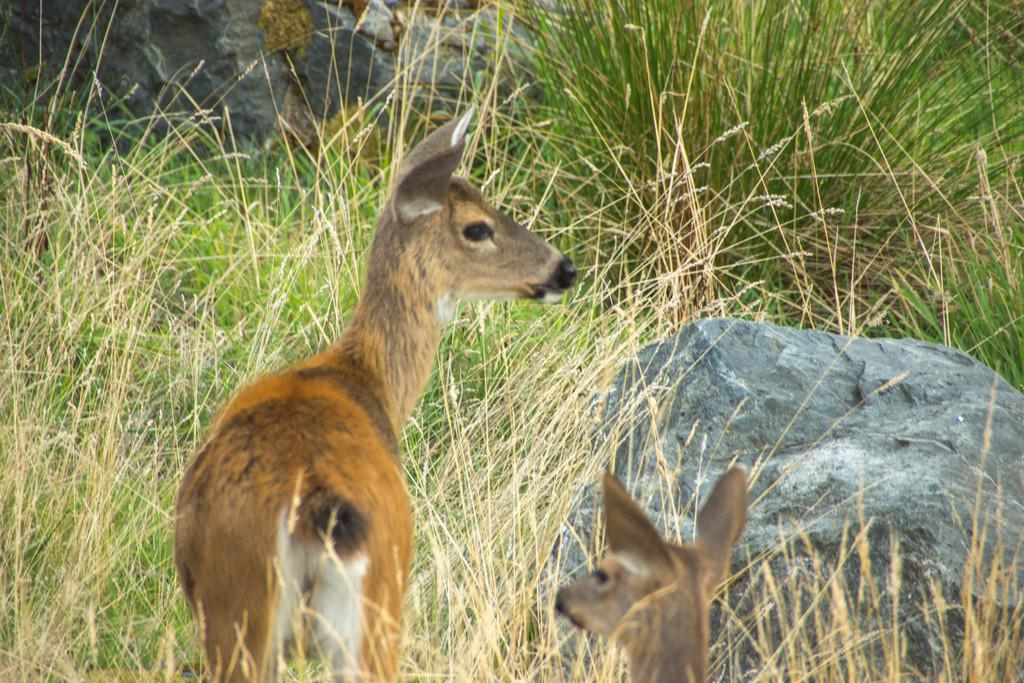What animals are present in the image? There are deer in the image. What is the position of the deer in the image? The deer are standing on the ground. What type of terrain is visible in the image? There are rocks and grass on the ground. What type of net can be seen in the image? There is no net present in the image; it features deer standing on the ground with rocks and grass. Can you tell me how many giraffes are visible in the image? There are no giraffes present in the image; it features deer. 